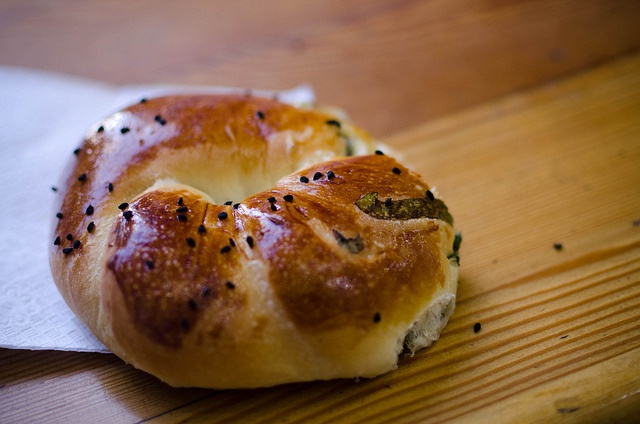Describe the objects in this image and their specific colors. I can see a donut in gray, maroon, and brown tones in this image. 